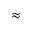<formula> <loc_0><loc_0><loc_500><loc_500>\approx</formula> 